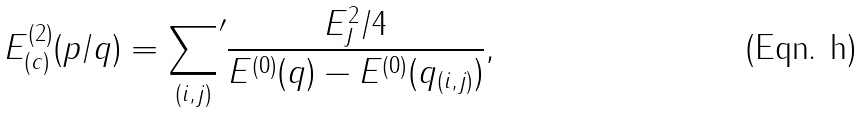Convert formula to latex. <formula><loc_0><loc_0><loc_500><loc_500>E _ { ( c ) } ^ { ( 2 ) } ( p / q ) = { \sum _ { ( i , j ) } } ^ { \prime } \frac { E _ { J } ^ { 2 } / 4 } { E ^ { ( 0 ) } ( { q } ) - E ^ { ( 0 ) } ( { q } _ { ( i , j ) } ) } ,</formula> 